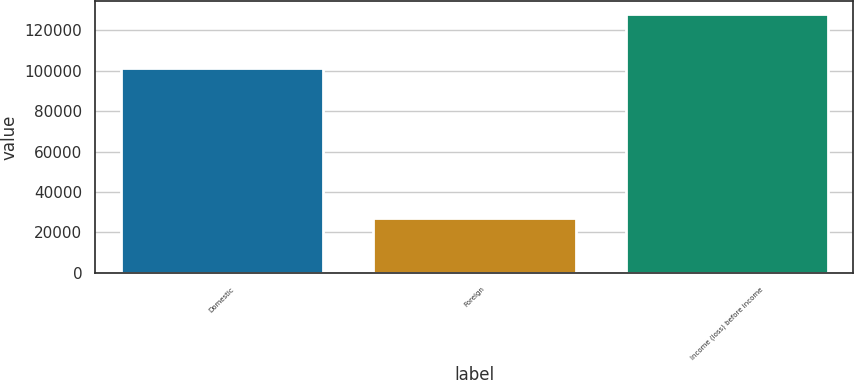<chart> <loc_0><loc_0><loc_500><loc_500><bar_chart><fcel>Domestic<fcel>Foreign<fcel>Income (loss) before income<nl><fcel>101328<fcel>26887<fcel>128215<nl></chart> 